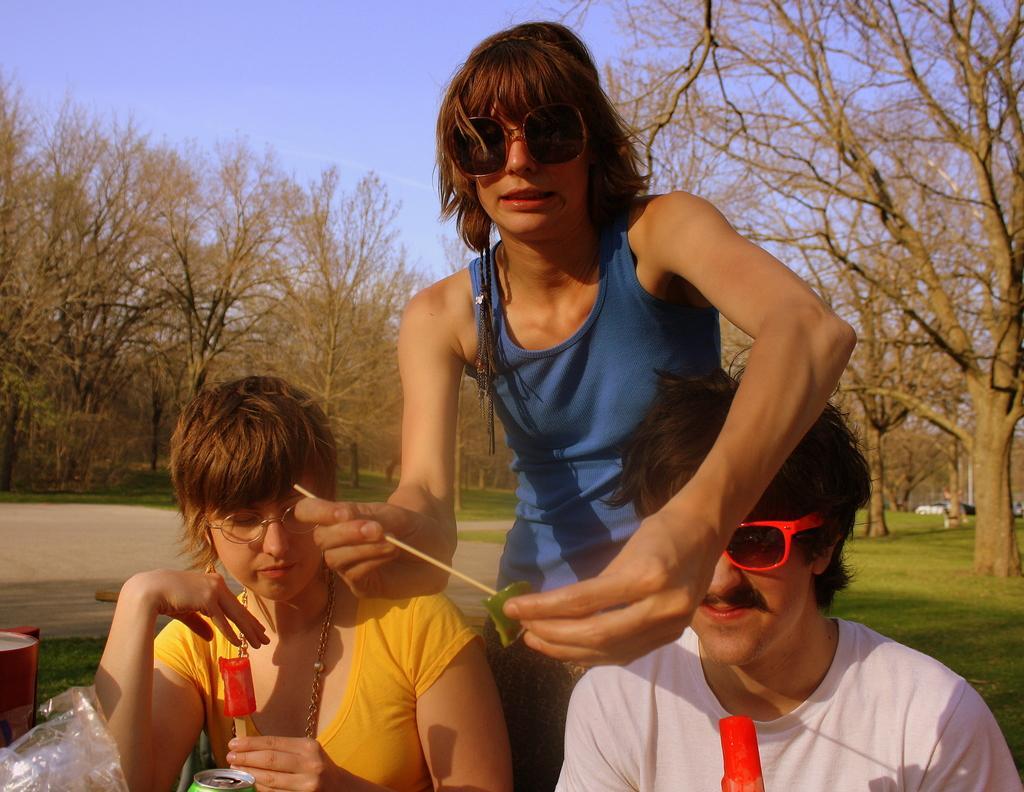Describe this image in one or two sentences. At the bottom of the picture, we see a man and the women are sitting on the chairs. They are holding ice cream sticks in their hands. In front of them, we see coke bottle and plastic cover. On the left side, we see something in red color. On the right side, we see grass. There are trees in the background. At the top of the picture, we see the sky. 